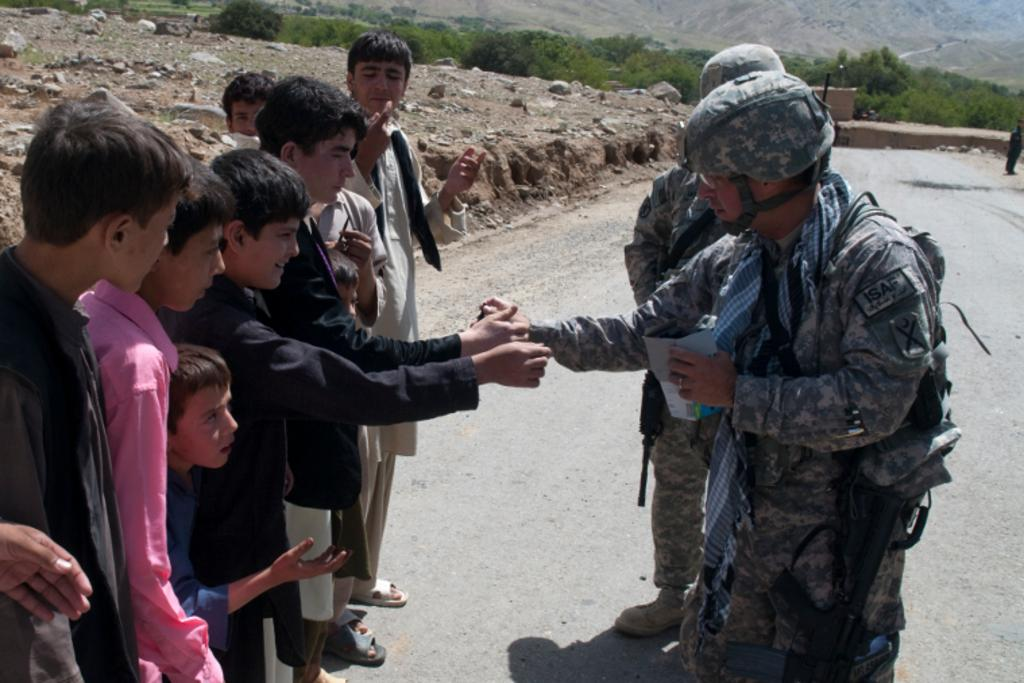What can be seen in the image? There are people standing in the image, and they are wearing uniforms. Where are the children located in the image? The children are on the left side of the image. What is at the bottom of the image? There is a road at the bottom of the image. What can be seen in the background of the image? There are trees and hills in the background of the image. What type of toe is visible in the image? There are no toes visible in the image; it features people standing and wearing uniforms, as well as children, a road, trees, and hills in the background. 